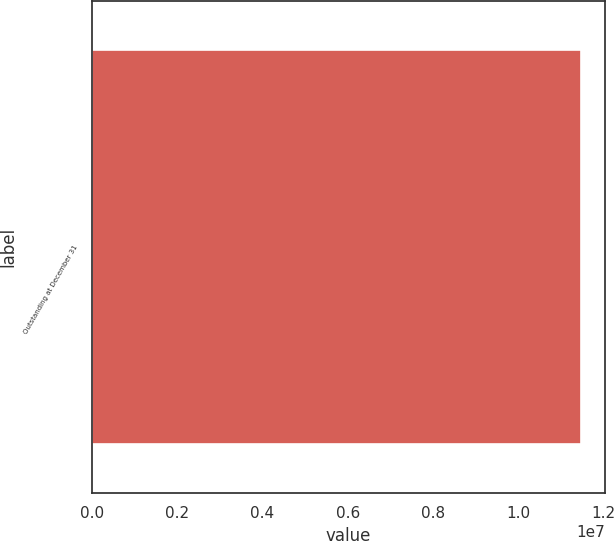<chart> <loc_0><loc_0><loc_500><loc_500><bar_chart><fcel>Outstanding at December 31<nl><fcel>1.14597e+07<nl></chart> 